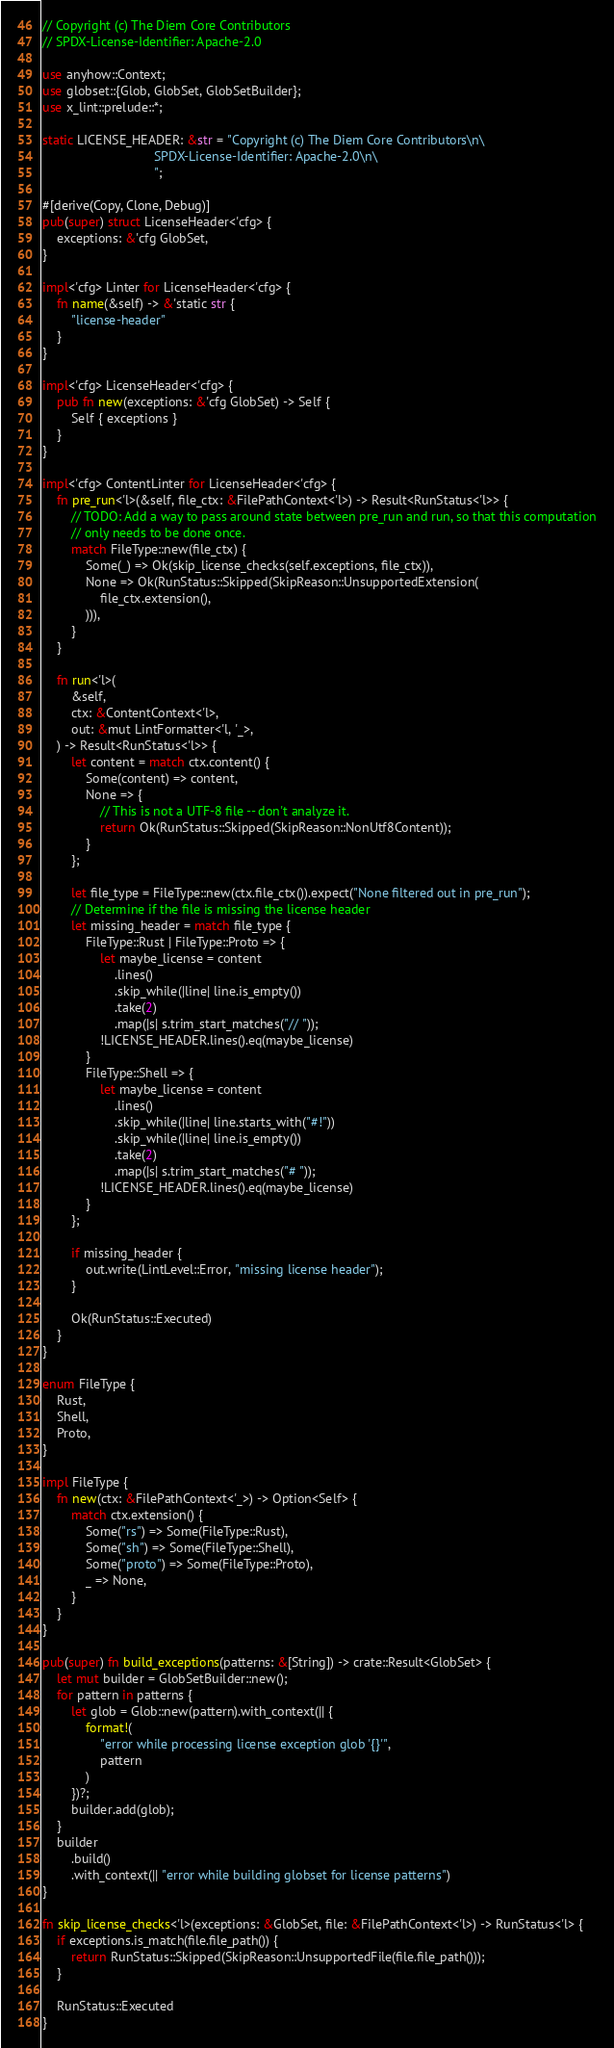Convert code to text. <code><loc_0><loc_0><loc_500><loc_500><_Rust_>// Copyright (c) The Diem Core Contributors
// SPDX-License-Identifier: Apache-2.0

use anyhow::Context;
use globset::{Glob, GlobSet, GlobSetBuilder};
use x_lint::prelude::*;

static LICENSE_HEADER: &str = "Copyright (c) The Diem Core Contributors\n\
                               SPDX-License-Identifier: Apache-2.0\n\
                               ";

#[derive(Copy, Clone, Debug)]
pub(super) struct LicenseHeader<'cfg> {
    exceptions: &'cfg GlobSet,
}

impl<'cfg> Linter for LicenseHeader<'cfg> {
    fn name(&self) -> &'static str {
        "license-header"
    }
}

impl<'cfg> LicenseHeader<'cfg> {
    pub fn new(exceptions: &'cfg GlobSet) -> Self {
        Self { exceptions }
    }
}

impl<'cfg> ContentLinter for LicenseHeader<'cfg> {
    fn pre_run<'l>(&self, file_ctx: &FilePathContext<'l>) -> Result<RunStatus<'l>> {
        // TODO: Add a way to pass around state between pre_run and run, so that this computation
        // only needs to be done once.
        match FileType::new(file_ctx) {
            Some(_) => Ok(skip_license_checks(self.exceptions, file_ctx)),
            None => Ok(RunStatus::Skipped(SkipReason::UnsupportedExtension(
                file_ctx.extension(),
            ))),
        }
    }

    fn run<'l>(
        &self,
        ctx: &ContentContext<'l>,
        out: &mut LintFormatter<'l, '_>,
    ) -> Result<RunStatus<'l>> {
        let content = match ctx.content() {
            Some(content) => content,
            None => {
                // This is not a UTF-8 file -- don't analyze it.
                return Ok(RunStatus::Skipped(SkipReason::NonUtf8Content));
            }
        };

        let file_type = FileType::new(ctx.file_ctx()).expect("None filtered out in pre_run");
        // Determine if the file is missing the license header
        let missing_header = match file_type {
            FileType::Rust | FileType::Proto => {
                let maybe_license = content
                    .lines()
                    .skip_while(|line| line.is_empty())
                    .take(2)
                    .map(|s| s.trim_start_matches("// "));
                !LICENSE_HEADER.lines().eq(maybe_license)
            }
            FileType::Shell => {
                let maybe_license = content
                    .lines()
                    .skip_while(|line| line.starts_with("#!"))
                    .skip_while(|line| line.is_empty())
                    .take(2)
                    .map(|s| s.trim_start_matches("# "));
                !LICENSE_HEADER.lines().eq(maybe_license)
            }
        };

        if missing_header {
            out.write(LintLevel::Error, "missing license header");
        }

        Ok(RunStatus::Executed)
    }
}

enum FileType {
    Rust,
    Shell,
    Proto,
}

impl FileType {
    fn new(ctx: &FilePathContext<'_>) -> Option<Self> {
        match ctx.extension() {
            Some("rs") => Some(FileType::Rust),
            Some("sh") => Some(FileType::Shell),
            Some("proto") => Some(FileType::Proto),
            _ => None,
        }
    }
}

pub(super) fn build_exceptions(patterns: &[String]) -> crate::Result<GlobSet> {
    let mut builder = GlobSetBuilder::new();
    for pattern in patterns {
        let glob = Glob::new(pattern).with_context(|| {
            format!(
                "error while processing license exception glob '{}'",
                pattern
            )
        })?;
        builder.add(glob);
    }
    builder
        .build()
        .with_context(|| "error while building globset for license patterns")
}

fn skip_license_checks<'l>(exceptions: &GlobSet, file: &FilePathContext<'l>) -> RunStatus<'l> {
    if exceptions.is_match(file.file_path()) {
        return RunStatus::Skipped(SkipReason::UnsupportedFile(file.file_path()));
    }

    RunStatus::Executed
}
</code> 